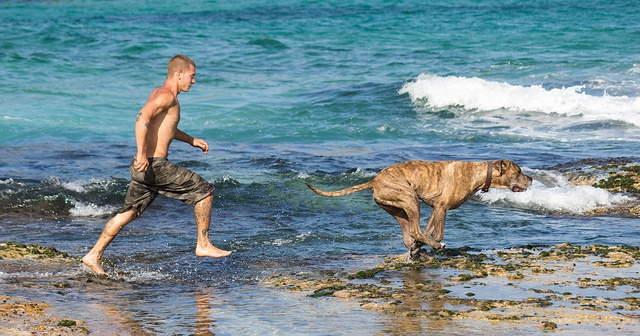Describe the objects in this image and their specific colors. I can see people in teal, gray, tan, and black tones and dog in teal, tan, and gray tones in this image. 